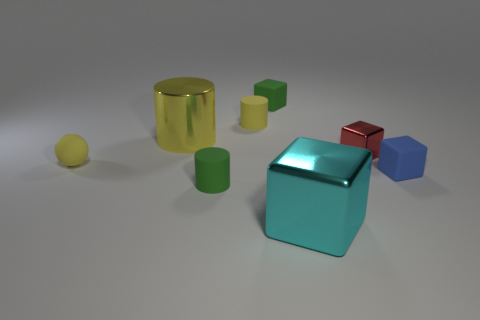What shape is the big shiny object that is the same color as the tiny sphere? cylinder 